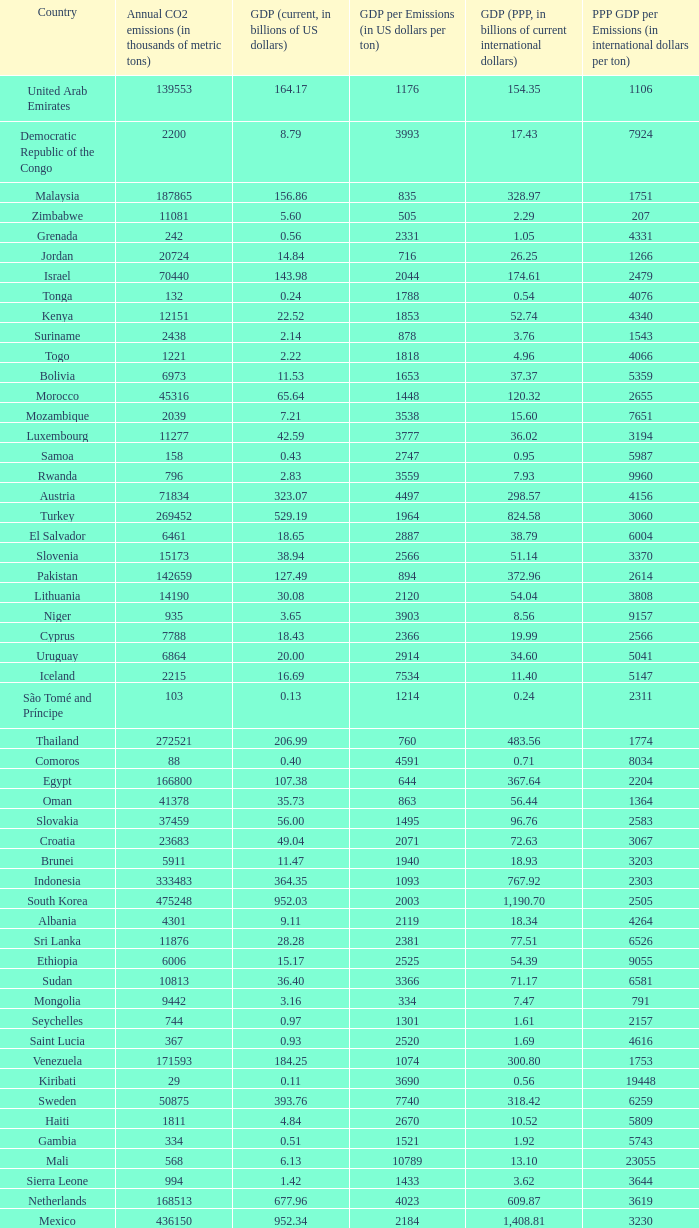When the gdp (ppp, in billions of current international dollars) is 7.93, what is the maximum ppp gdp per emissions (in international dollars per ton)? 9960.0. 